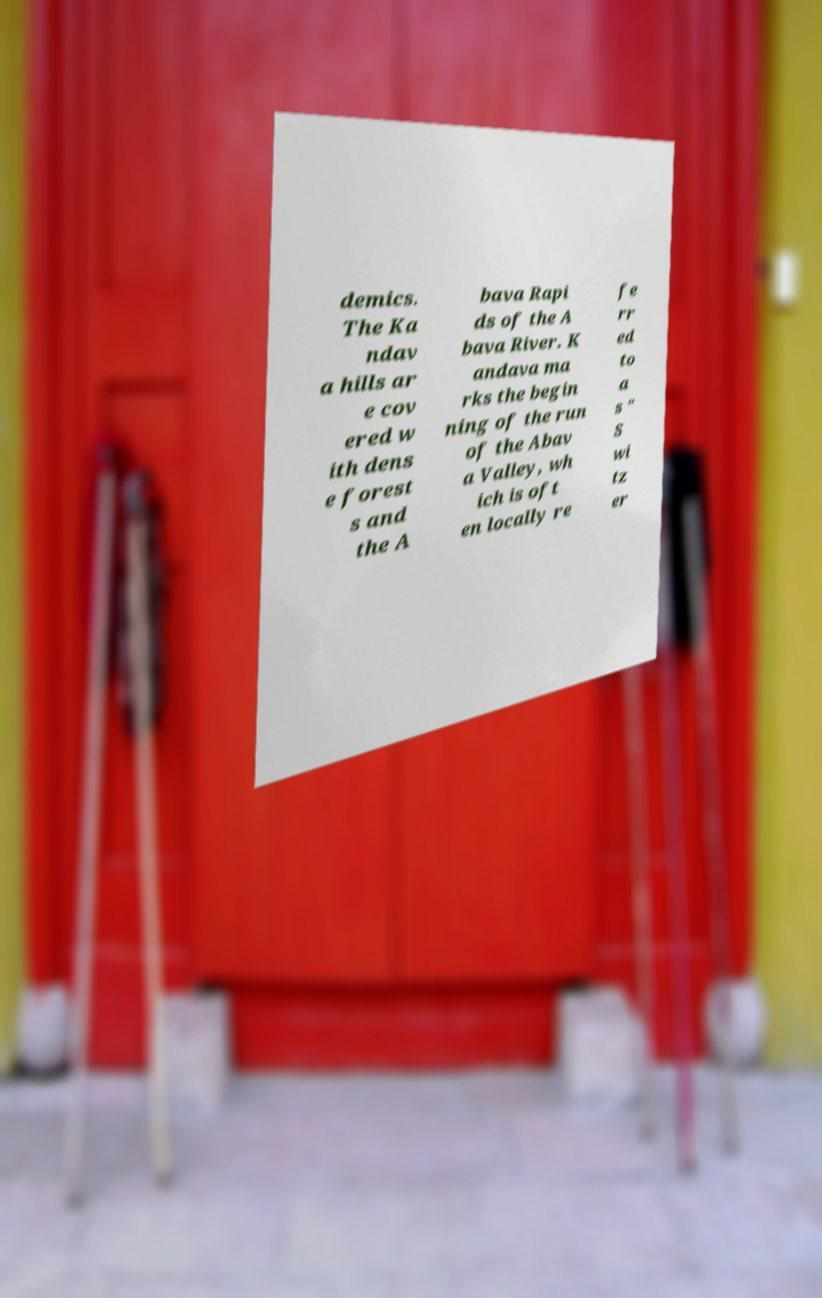Please read and relay the text visible in this image. What does it say? demics. The Ka ndav a hills ar e cov ered w ith dens e forest s and the A bava Rapi ds of the A bava River. K andava ma rks the begin ning of the run of the Abav a Valley, wh ich is oft en locally re fe rr ed to a s " S wi tz er 